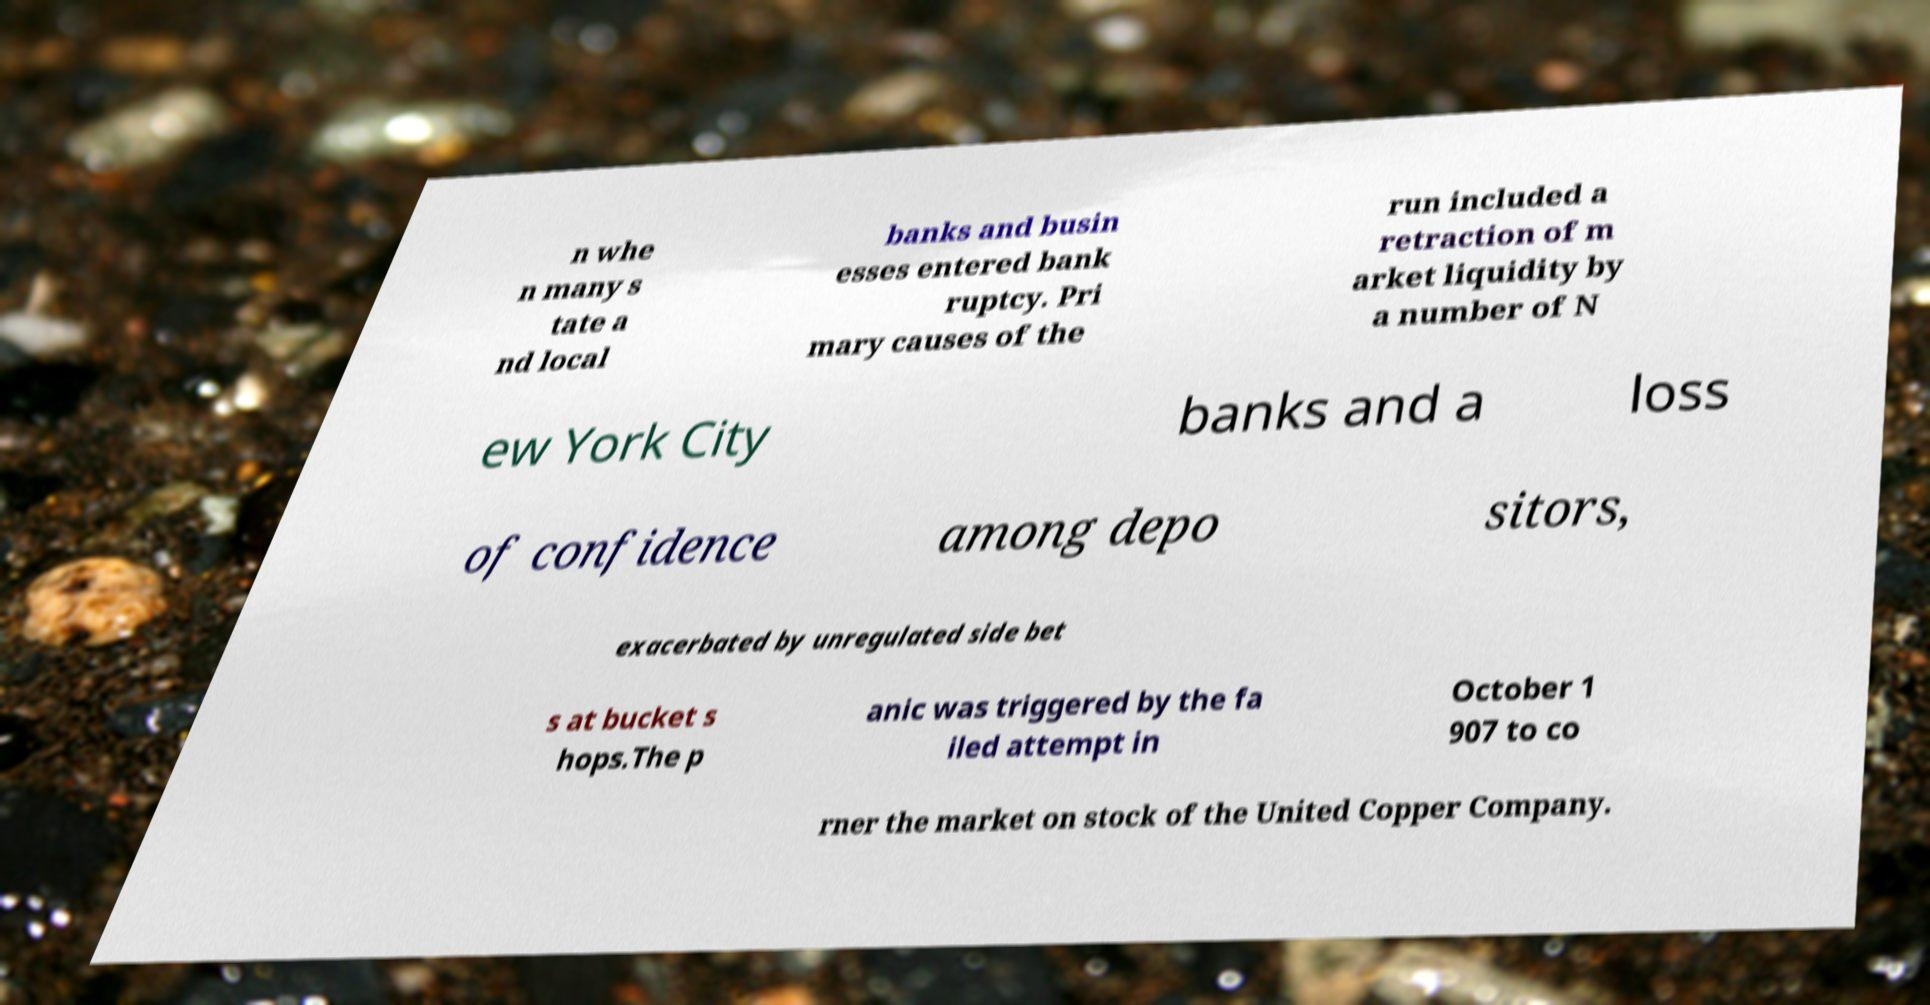For documentation purposes, I need the text within this image transcribed. Could you provide that? n whe n many s tate a nd local banks and busin esses entered bank ruptcy. Pri mary causes of the run included a retraction of m arket liquidity by a number of N ew York City banks and a loss of confidence among depo sitors, exacerbated by unregulated side bet s at bucket s hops.The p anic was triggered by the fa iled attempt in October 1 907 to co rner the market on stock of the United Copper Company. 